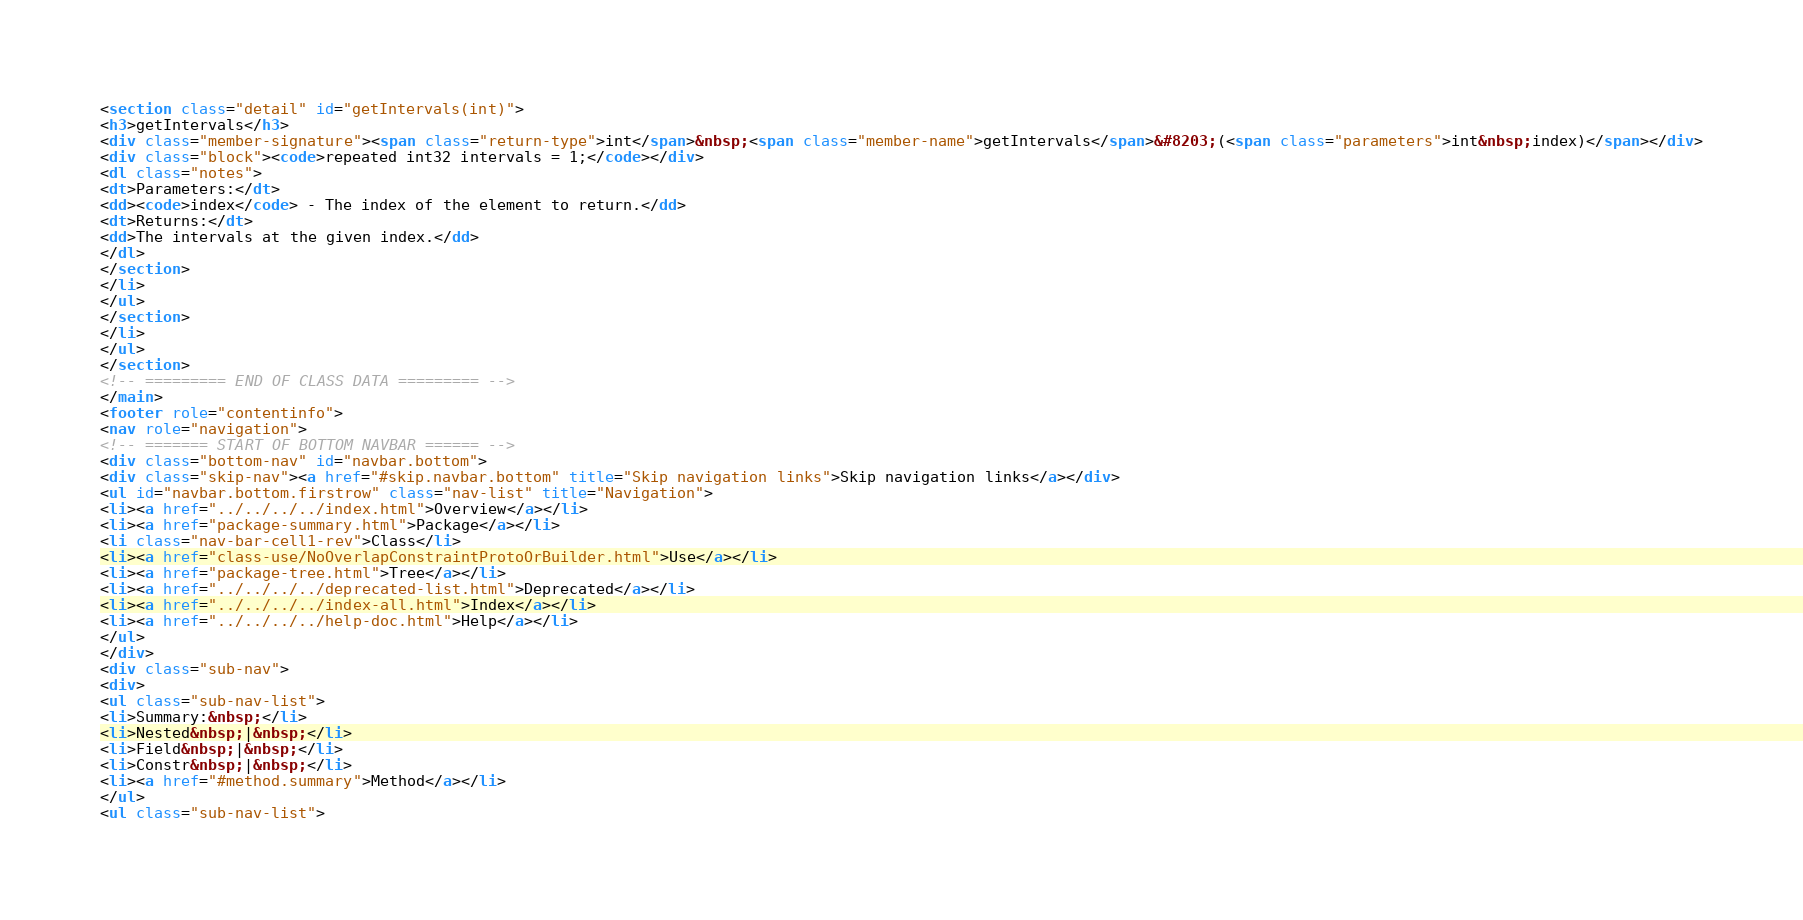<code> <loc_0><loc_0><loc_500><loc_500><_HTML_><section class="detail" id="getIntervals(int)">
<h3>getIntervals</h3>
<div class="member-signature"><span class="return-type">int</span>&nbsp;<span class="member-name">getIntervals</span>&#8203;(<span class="parameters">int&nbsp;index)</span></div>
<div class="block"><code>repeated int32 intervals = 1;</code></div>
<dl class="notes">
<dt>Parameters:</dt>
<dd><code>index</code> - The index of the element to return.</dd>
<dt>Returns:</dt>
<dd>The intervals at the given index.</dd>
</dl>
</section>
</li>
</ul>
</section>
</li>
</ul>
</section>
<!-- ========= END OF CLASS DATA ========= -->
</main>
<footer role="contentinfo">
<nav role="navigation">
<!-- ======= START OF BOTTOM NAVBAR ====== -->
<div class="bottom-nav" id="navbar.bottom">
<div class="skip-nav"><a href="#skip.navbar.bottom" title="Skip navigation links">Skip navigation links</a></div>
<ul id="navbar.bottom.firstrow" class="nav-list" title="Navigation">
<li><a href="../../../../index.html">Overview</a></li>
<li><a href="package-summary.html">Package</a></li>
<li class="nav-bar-cell1-rev">Class</li>
<li><a href="class-use/NoOverlapConstraintProtoOrBuilder.html">Use</a></li>
<li><a href="package-tree.html">Tree</a></li>
<li><a href="../../../../deprecated-list.html">Deprecated</a></li>
<li><a href="../../../../index-all.html">Index</a></li>
<li><a href="../../../../help-doc.html">Help</a></li>
</ul>
</div>
<div class="sub-nav">
<div>
<ul class="sub-nav-list">
<li>Summary:&nbsp;</li>
<li>Nested&nbsp;|&nbsp;</li>
<li>Field&nbsp;|&nbsp;</li>
<li>Constr&nbsp;|&nbsp;</li>
<li><a href="#method.summary">Method</a></li>
</ul>
<ul class="sub-nav-list"></code> 